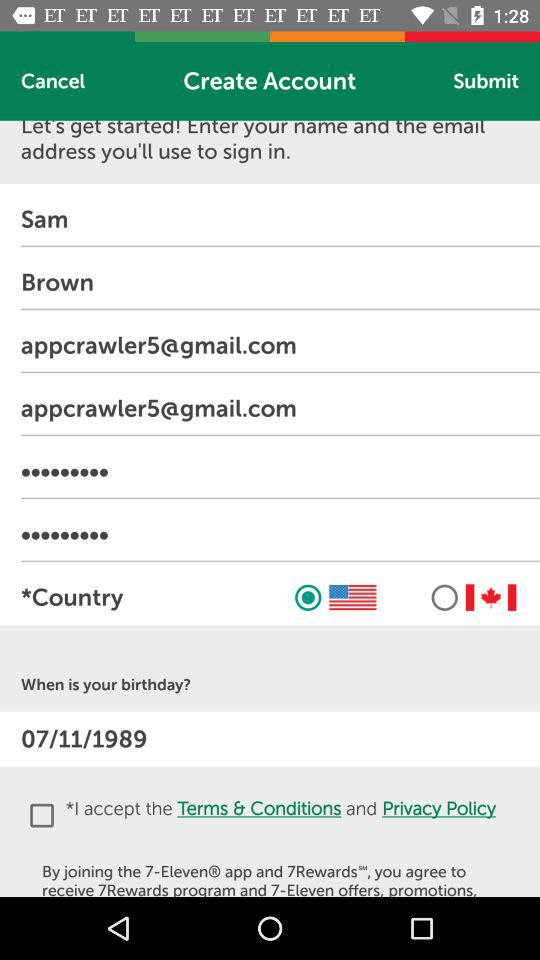Which country has been selected? The country that has been selected is the United States of America. 